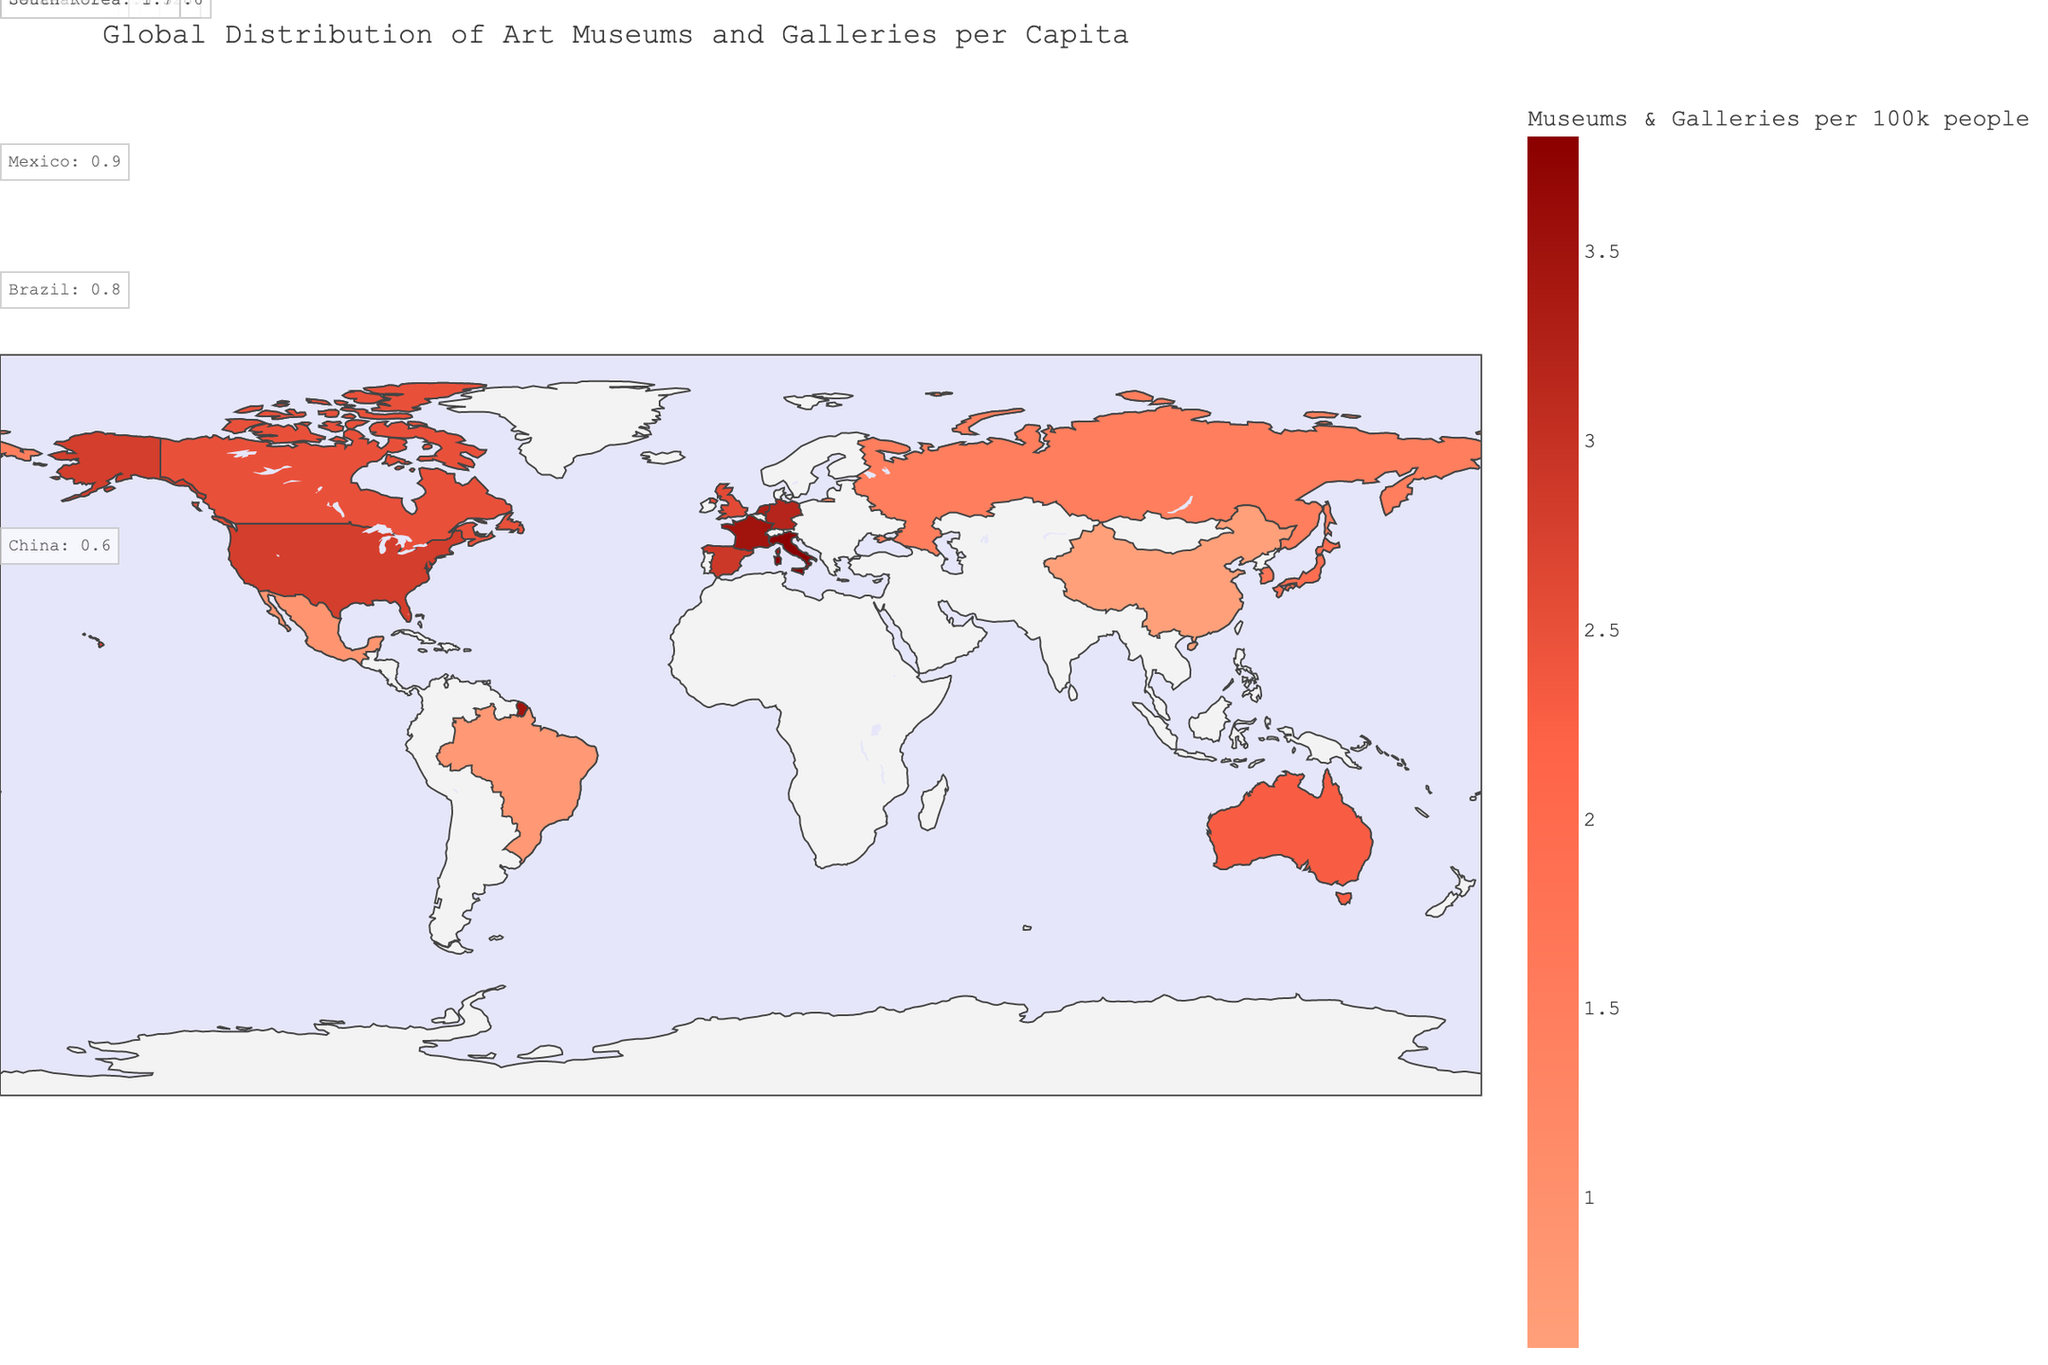What is the title of the figure? The title is usually positioned at the top of the figure and contains the description of the plot. In this case, it reads "Global Distribution of Art Museums and Galleries per Capita."
Answer: Global Distribution of Art Museums and Galleries per Capita Which country has the highest number of art museums and galleries per 100k people? To find the country with the highest number, we look for the highest bar or colored section corresponding to the data point with the most intense color on the color scale. The data shows Italy has the highest value at 3.8 per 100k people.
Answer: Italy What is the notable abstract museum in Germany? By observing the figure's hover data or annotated text, we find that Germany's notable abstract museum is listed as "Museum Ludwig."
Answer: Museum Ludwig Which region generally has a higher concentration of art museums and galleries per 100k people, Europe or Asia? We compare the average value of the European countries to the Asian countries from the data on the map. European countries like France (3.5), Germany (3.2), Italy (3.8) have high values, whereas Asian countries like Japan (1.9), China (0.6), South Korea (1.7) have lower values on average.
Answer: Europe How does the number of art museums and galleries per 100k people in the United States compare to Canada? We need to look at the values for both countries. The United States has 2.8 and Canada has 2.5, so the United States has a slightly higher number.
Answer: The United States has more Which country in South America is shown on the figure and what is its Museums_Galleries_per_100k value? By referring to the figure and noting the geographic region and provided data, Brazil is listed under South America with a value of 0.8 per 100k people.
Answer: Brazil, 0.8 What is the average number of art museums and galleries per 100k people in Europe based on the given data? We calculate the average by summing the values for European countries (France 3.5, Germany 3.2, Spain 2.9, United Kingdom 2.6, Russia 1.5, Italy 3.8, Netherlands 3.3) and dividing by the number of countries. (3.5 + 3.2 + 2.9 + 2.6 + 1.5 + 3.8 + 3.3) / 7 = 20.8 / 7 = 2.97.
Answer: 2.97 Which continent appears to have the most consistent values for Museums_Galleries_per_100k people? By observing the choropleth map and noting the variance in color intensity and values, Europe seems to have more consistent values around 2.6 to 3.8, compared to other continents with higher variance.
Answer: Europe What is the notable abstract museum in Australia, and how many art museums and galleries per 100k people are there? The notable abstract museum in Australia can be found in the hover data or annotations, listed as "Museum of Contemporary Art Australia" with a value of 2.3 per 100k people.
Answer: Museum of Contemporary Art Australia, 2.3 Among the countries listed, which has the lowest number of art museums and galleries per 100k people? By identifying the smallest value, we find that China has the lowest number with 0.6 per 100k people.
Answer: China 